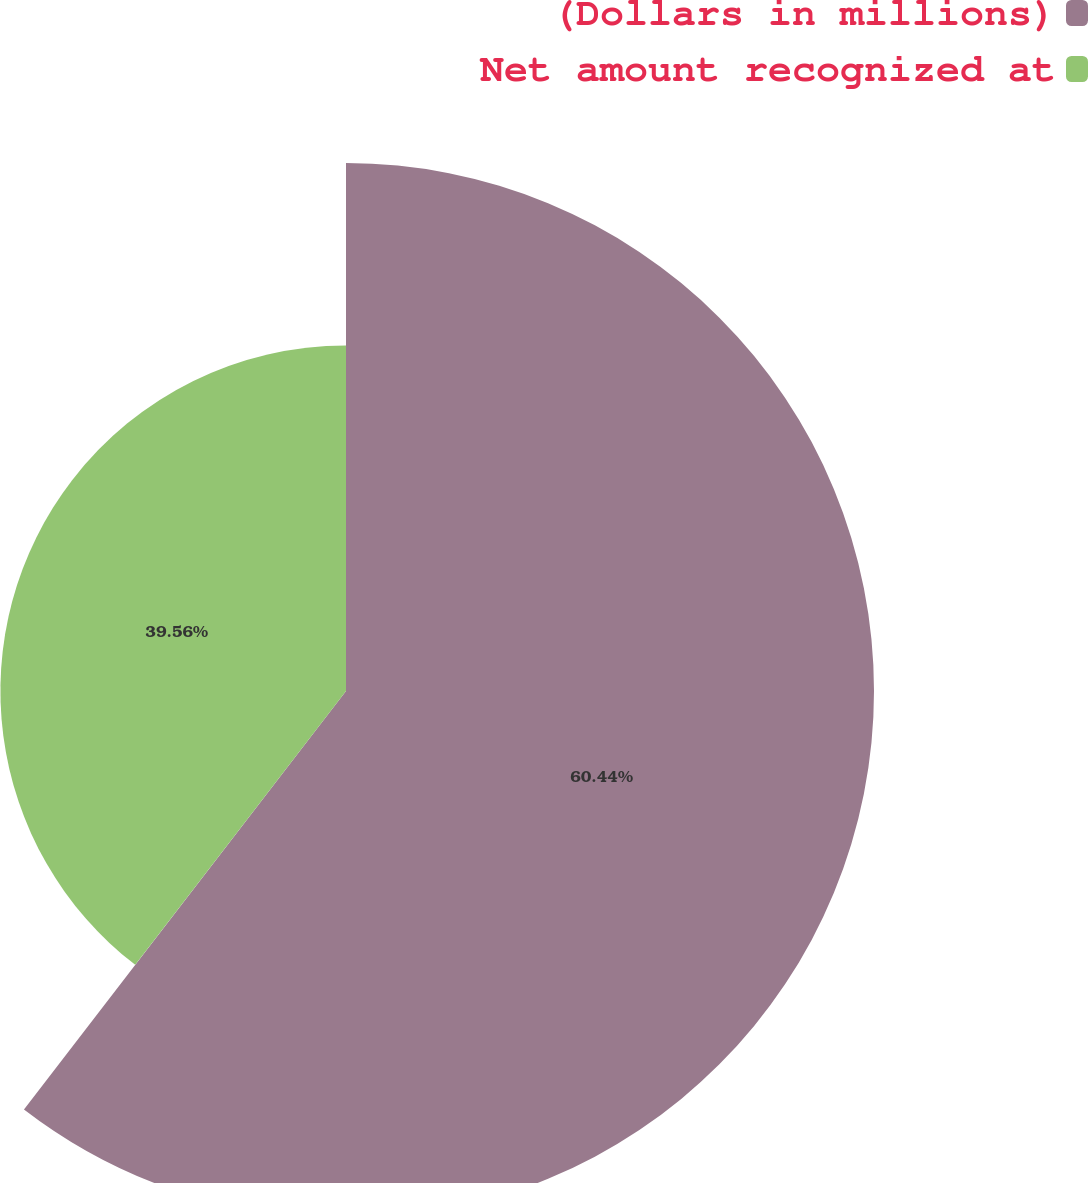<chart> <loc_0><loc_0><loc_500><loc_500><pie_chart><fcel>(Dollars in millions)<fcel>Net amount recognized at<nl><fcel>60.44%<fcel>39.56%<nl></chart> 